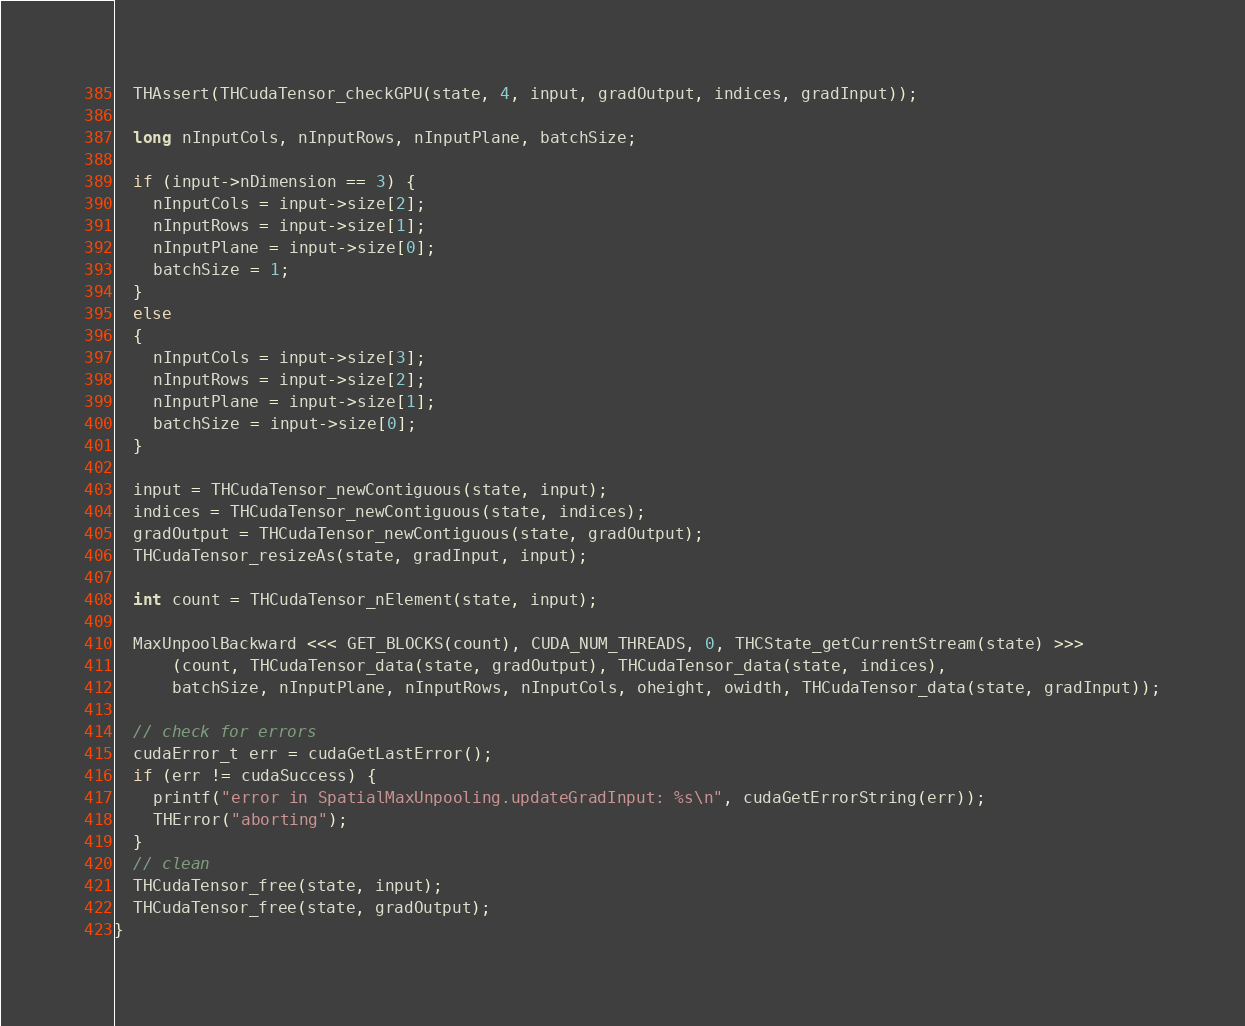Convert code to text. <code><loc_0><loc_0><loc_500><loc_500><_Cuda_>  THAssert(THCudaTensor_checkGPU(state, 4, input, gradOutput, indices, gradInput));

  long nInputCols, nInputRows, nInputPlane, batchSize;

  if (input->nDimension == 3) {
    nInputCols = input->size[2];
    nInputRows = input->size[1];
    nInputPlane = input->size[0];
    batchSize = 1;
  }
  else
  {
    nInputCols = input->size[3];
    nInputRows = input->size[2];
    nInputPlane = input->size[1];
    batchSize = input->size[0];
  }

  input = THCudaTensor_newContiguous(state, input);
  indices = THCudaTensor_newContiguous(state, indices);
  gradOutput = THCudaTensor_newContiguous(state, gradOutput);
  THCudaTensor_resizeAs(state, gradInput, input);
  
  int count = THCudaTensor_nElement(state, input);

  MaxUnpoolBackward <<< GET_BLOCKS(count), CUDA_NUM_THREADS, 0, THCState_getCurrentStream(state) >>> 
      (count, THCudaTensor_data(state, gradOutput), THCudaTensor_data(state, indices),
      batchSize, nInputPlane, nInputRows, nInputCols, oheight, owidth, THCudaTensor_data(state, gradInput));

  // check for errors
  cudaError_t err = cudaGetLastError();
  if (err != cudaSuccess) {
    printf("error in SpatialMaxUnpooling.updateGradInput: %s\n", cudaGetErrorString(err));
    THError("aborting");
  }
  // clean
  THCudaTensor_free(state, input);
  THCudaTensor_free(state, gradOutput);
}
</code> 